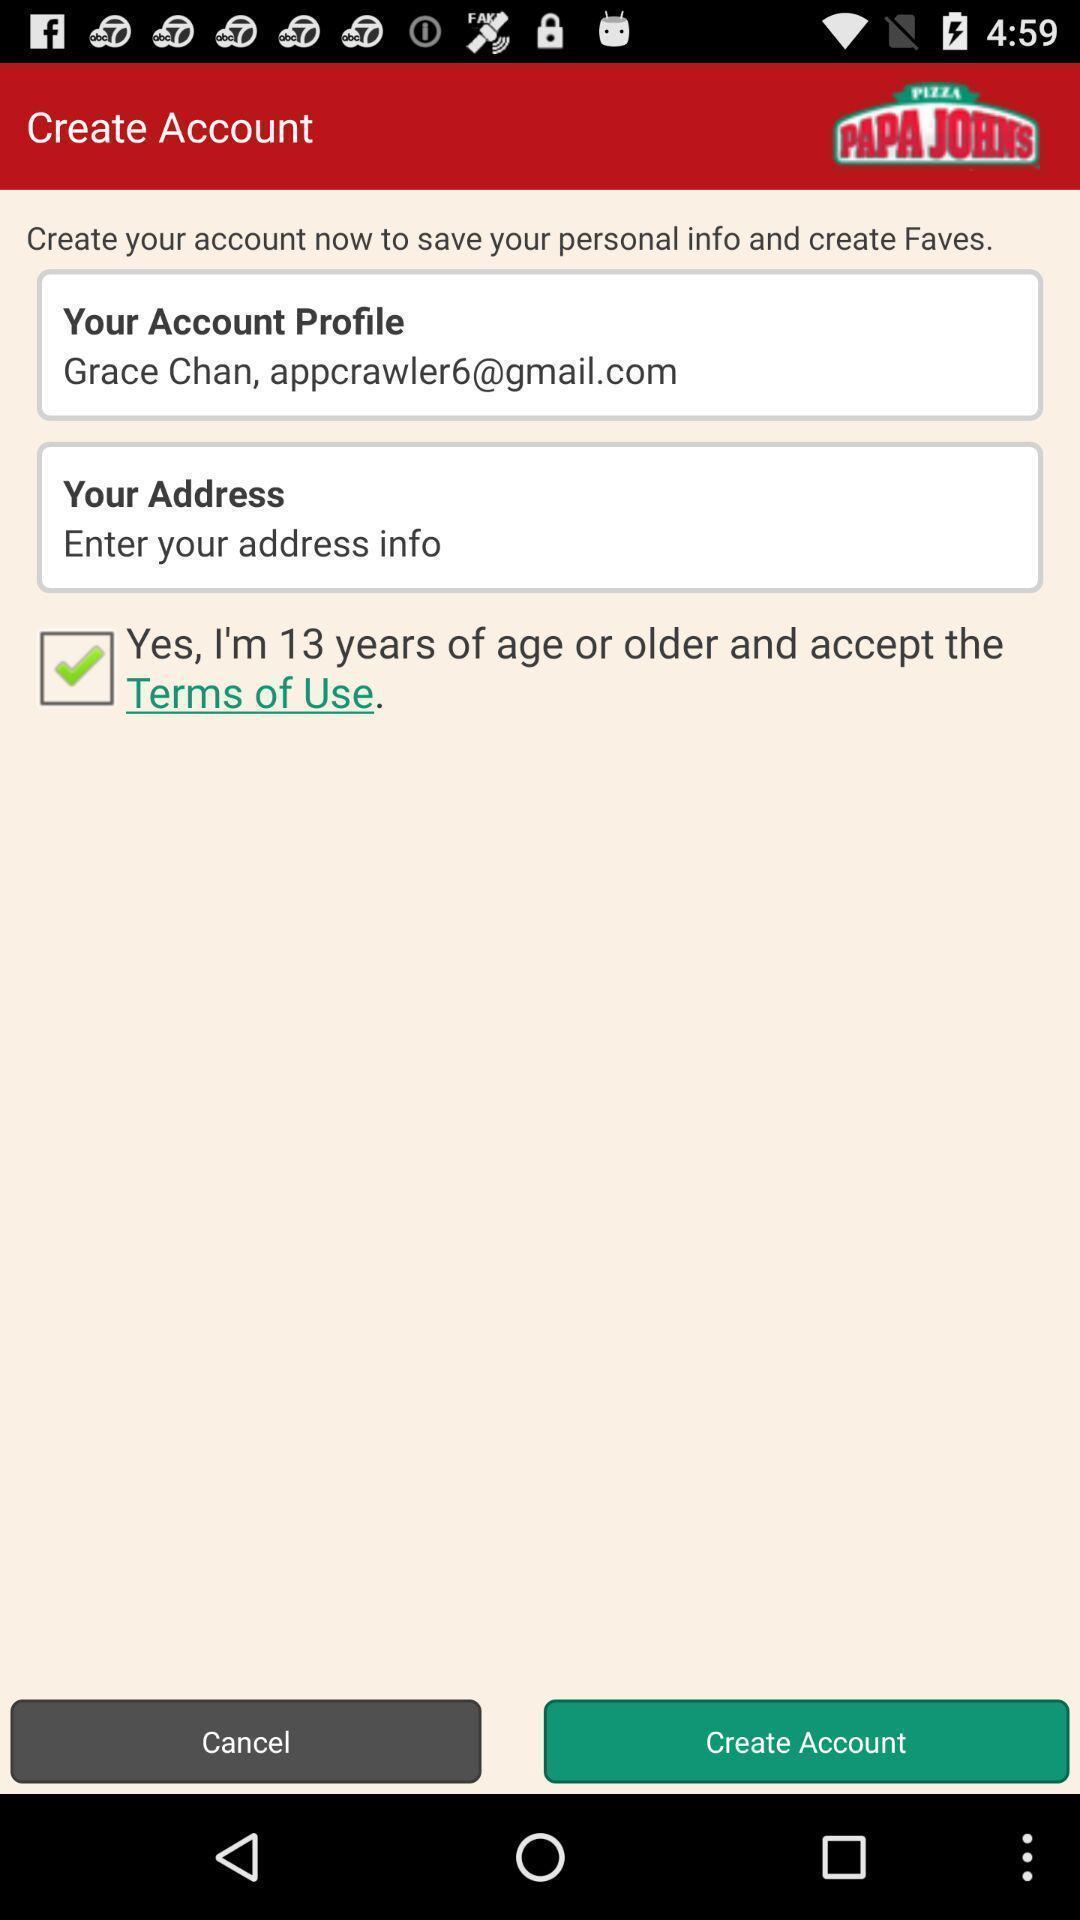Provide a description of this screenshot. Screen showing page to create account. 